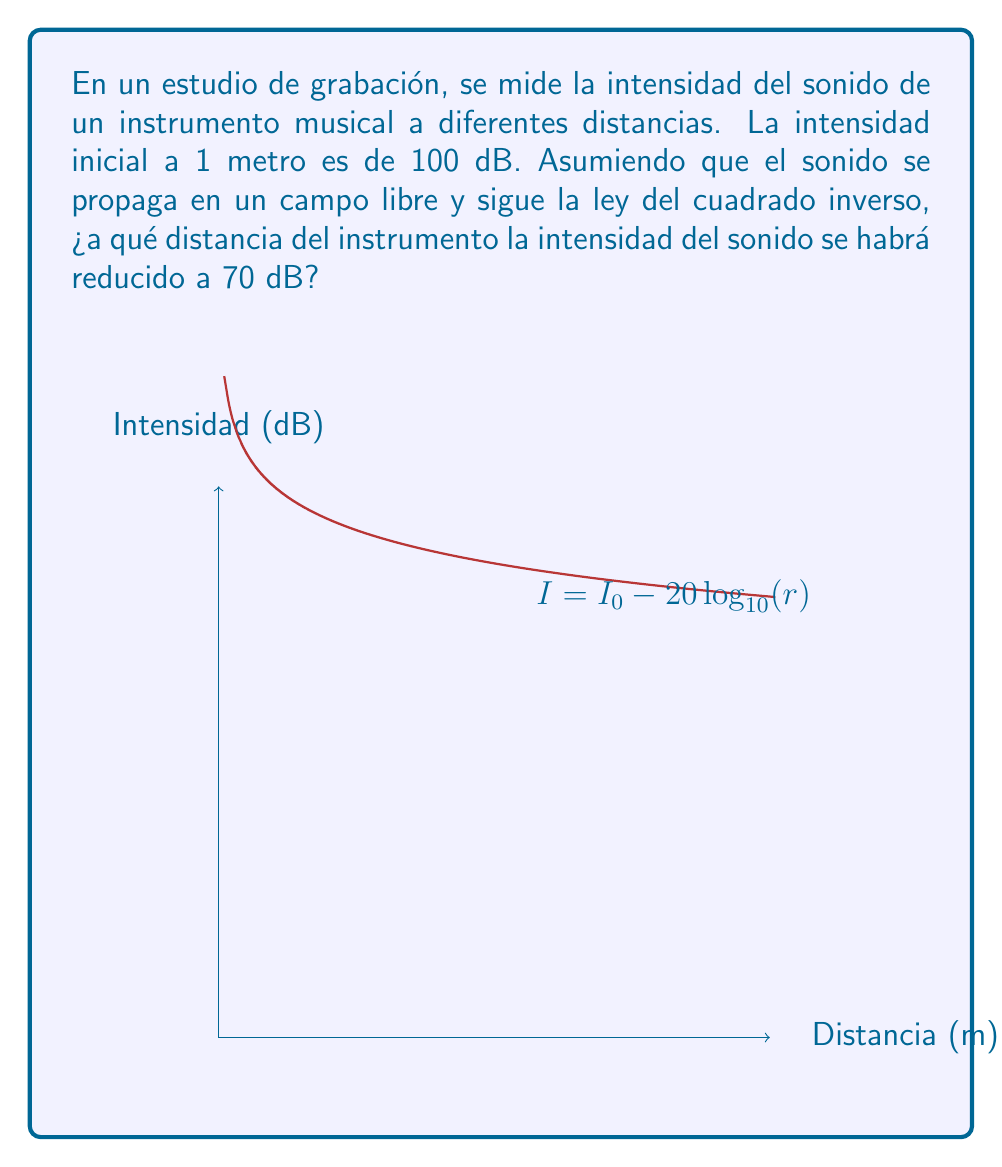Can you answer this question? Para resolver este problema, seguiremos estos pasos:

1) La ley del cuadrado inverso para la intensidad del sonido en un campo libre se puede expresar como:

   $$ I = I_0 - 20\log_{10}(r) $$

   Donde $I$ es la intensidad en dB a una distancia $r$, e $I_0$ es la intensidad inicial a 1 metro.

2) Tenemos los siguientes datos:
   $I_0 = 100$ dB (intensidad inicial a 1 metro)
   $I = 70$ dB (intensidad final que queremos alcanzar)
   $r$ es la distancia que queremos calcular

3) Sustituyamos estos valores en la ecuación:

   $$ 70 = 100 - 20\log_{10}(r) $$

4) Resolvamos para $r$:
   
   $$ -30 = -20\log_{10}(r) $$
   $$ 1.5 = \log_{10}(r) $$

5) Para despejar $r$, aplicamos $10^x$ a ambos lados:

   $$ 10^{1.5} = r $$

6) Calculamos el valor de $r$:

   $$ r \approx 31.62 \text{ metros} $$
Answer: $31.62$ m 